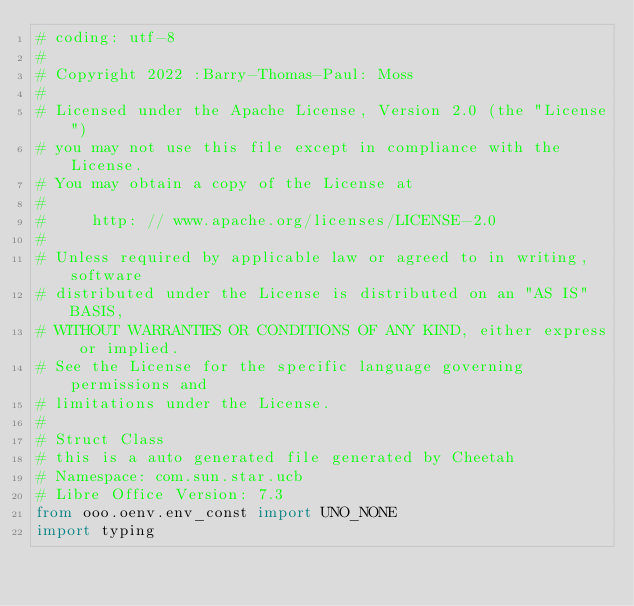Convert code to text. <code><loc_0><loc_0><loc_500><loc_500><_Python_># coding: utf-8
#
# Copyright 2022 :Barry-Thomas-Paul: Moss
#
# Licensed under the Apache License, Version 2.0 (the "License")
# you may not use this file except in compliance with the License.
# You may obtain a copy of the License at
#
#     http: // www.apache.org/licenses/LICENSE-2.0
#
# Unless required by applicable law or agreed to in writing, software
# distributed under the License is distributed on an "AS IS" BASIS,
# WITHOUT WARRANTIES OR CONDITIONS OF ANY KIND, either express or implied.
# See the License for the specific language governing permissions and
# limitations under the License.
#
# Struct Class
# this is a auto generated file generated by Cheetah
# Namespace: com.sun.star.ucb
# Libre Office Version: 7.3
from ooo.oenv.env_const import UNO_NONE
import typing</code> 